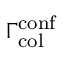Convert formula to latex. <formula><loc_0><loc_0><loc_500><loc_500>\Gamma _ { c o l } ^ { c o n f }</formula> 